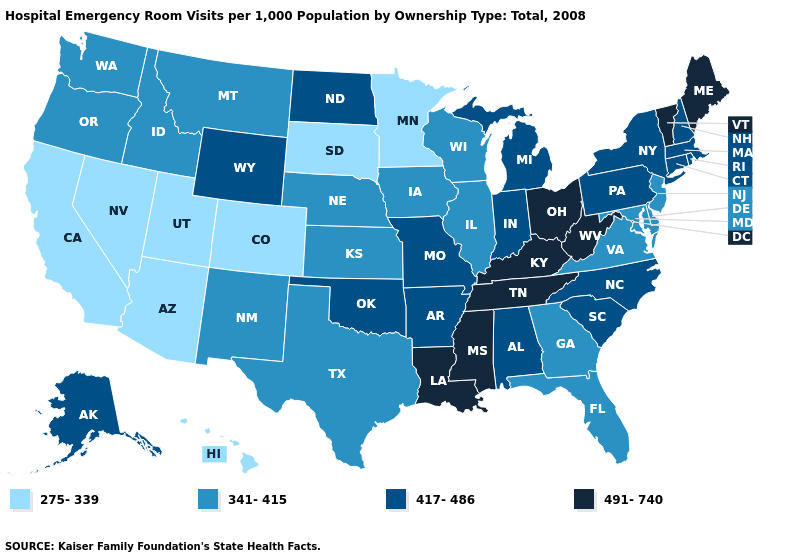What is the highest value in states that border South Carolina?
Give a very brief answer. 417-486. Does Vermont have the highest value in the Northeast?
Concise answer only. Yes. Name the states that have a value in the range 491-740?
Write a very short answer. Kentucky, Louisiana, Maine, Mississippi, Ohio, Tennessee, Vermont, West Virginia. Name the states that have a value in the range 275-339?
Give a very brief answer. Arizona, California, Colorado, Hawaii, Minnesota, Nevada, South Dakota, Utah. Name the states that have a value in the range 341-415?
Short answer required. Delaware, Florida, Georgia, Idaho, Illinois, Iowa, Kansas, Maryland, Montana, Nebraska, New Jersey, New Mexico, Oregon, Texas, Virginia, Washington, Wisconsin. What is the value of North Dakota?
Answer briefly. 417-486. Among the states that border Virginia , does Maryland have the lowest value?
Be succinct. Yes. Name the states that have a value in the range 341-415?
Give a very brief answer. Delaware, Florida, Georgia, Idaho, Illinois, Iowa, Kansas, Maryland, Montana, Nebraska, New Jersey, New Mexico, Oregon, Texas, Virginia, Washington, Wisconsin. What is the lowest value in the West?
Be succinct. 275-339. What is the value of New York?
Write a very short answer. 417-486. Among the states that border Colorado , which have the lowest value?
Short answer required. Arizona, Utah. Name the states that have a value in the range 491-740?
Write a very short answer. Kentucky, Louisiana, Maine, Mississippi, Ohio, Tennessee, Vermont, West Virginia. What is the value of New Jersey?
Short answer required. 341-415. What is the value of Hawaii?
Write a very short answer. 275-339. Name the states that have a value in the range 341-415?
Short answer required. Delaware, Florida, Georgia, Idaho, Illinois, Iowa, Kansas, Maryland, Montana, Nebraska, New Jersey, New Mexico, Oregon, Texas, Virginia, Washington, Wisconsin. 